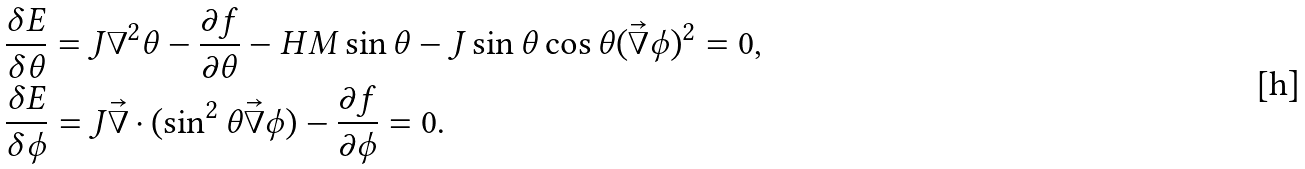Convert formula to latex. <formula><loc_0><loc_0><loc_500><loc_500>& \frac { \delta E } { \delta \theta } = J \nabla ^ { 2 } \theta - \frac { \partial f } { \partial \theta } - H M \sin \theta - J \sin \theta \cos \theta ( \vec { \nabla } \phi ) ^ { 2 } = 0 , \\ & \frac { \delta E } { \delta \phi } = J \vec { \nabla } \cdot ( \sin ^ { 2 } \theta \vec { \nabla } \phi ) - \frac { \partial f } { \partial \phi } = 0 .</formula> 